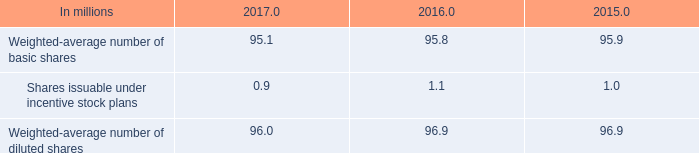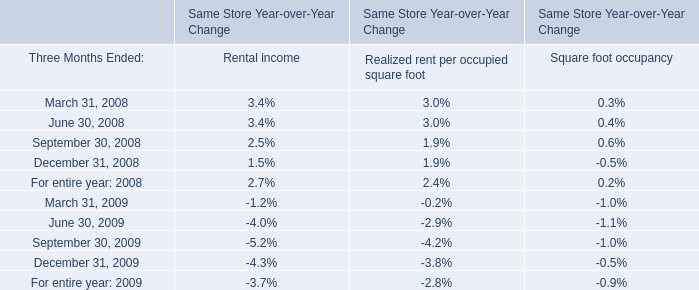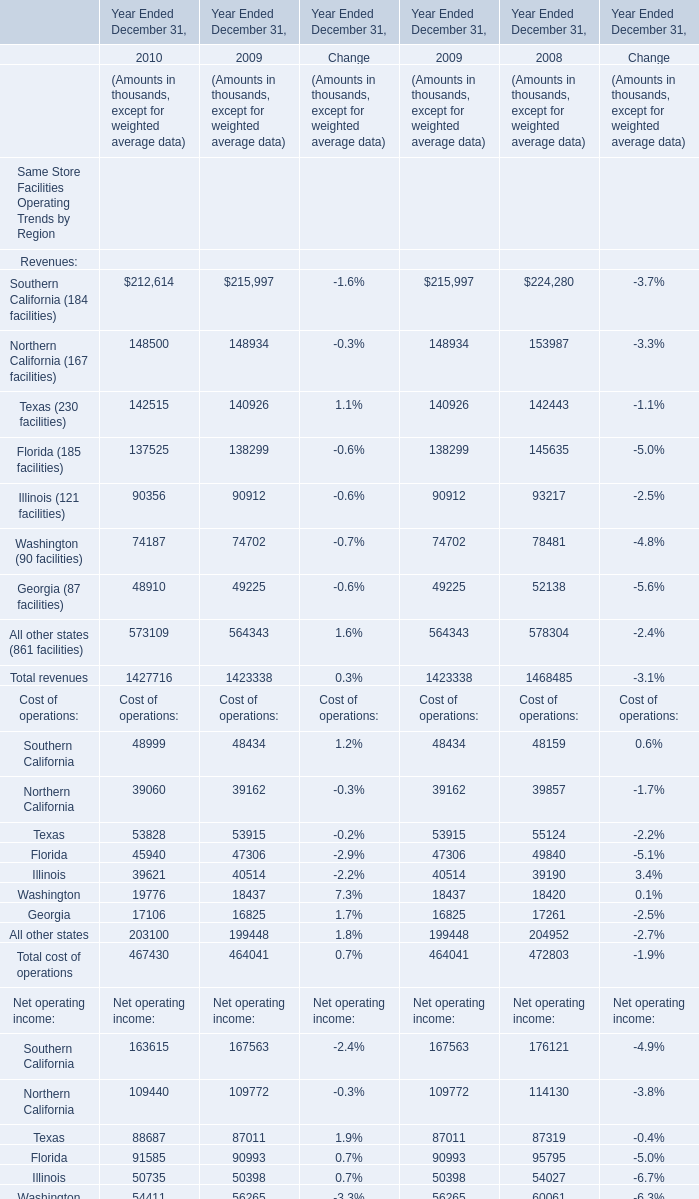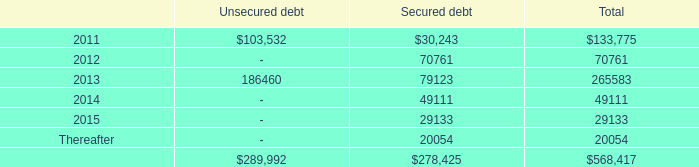If Texas (230 facilities) develops with the same growth rate in 2010, what will it reach in 2009? (in thousand) 
Computations: (142515 * (1 + ((142515 - 140926) / 140926)))
Answer: 144121.91664. 